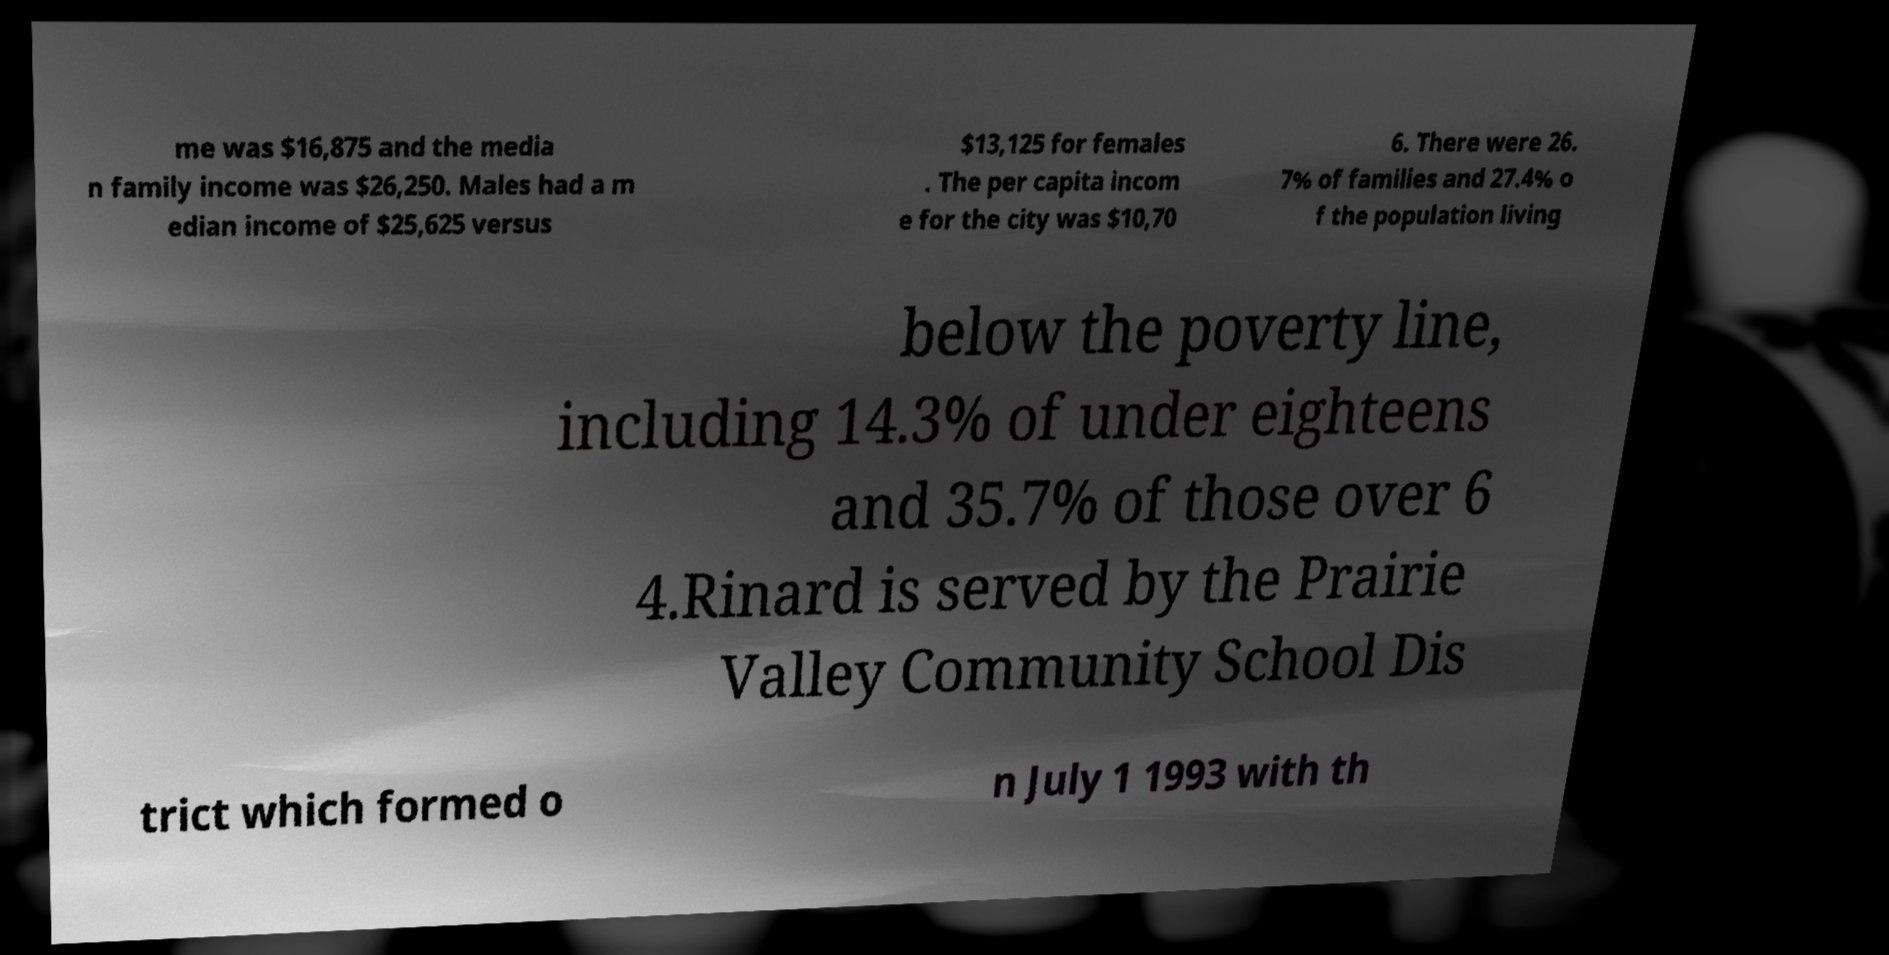Please read and relay the text visible in this image. What does it say? me was $16,875 and the media n family income was $26,250. Males had a m edian income of $25,625 versus $13,125 for females . The per capita incom e for the city was $10,70 6. There were 26. 7% of families and 27.4% o f the population living below the poverty line, including 14.3% of under eighteens and 35.7% of those over 6 4.Rinard is served by the Prairie Valley Community School Dis trict which formed o n July 1 1993 with th 